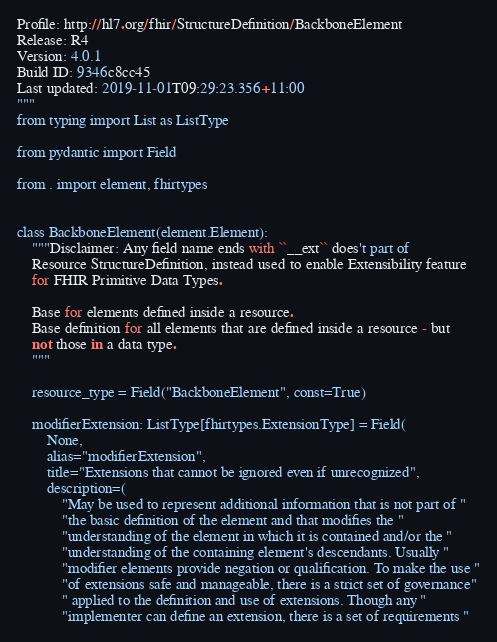<code> <loc_0><loc_0><loc_500><loc_500><_Python_>Profile: http://hl7.org/fhir/StructureDefinition/BackboneElement
Release: R4
Version: 4.0.1
Build ID: 9346c8cc45
Last updated: 2019-11-01T09:29:23.356+11:00
"""
from typing import List as ListType

from pydantic import Field

from . import element, fhirtypes


class BackboneElement(element.Element):
    """Disclaimer: Any field name ends with ``__ext`` does't part of
    Resource StructureDefinition, instead used to enable Extensibility feature
    for FHIR Primitive Data Types.

    Base for elements defined inside a resource.
    Base definition for all elements that are defined inside a resource - but
    not those in a data type.
    """

    resource_type = Field("BackboneElement", const=True)

    modifierExtension: ListType[fhirtypes.ExtensionType] = Field(
        None,
        alias="modifierExtension",
        title="Extensions that cannot be ignored even if unrecognized",
        description=(
            "May be used to represent additional information that is not part of "
            "the basic definition of the element and that modifies the "
            "understanding of the element in which it is contained and/or the "
            "understanding of the containing element's descendants. Usually "
            "modifier elements provide negation or qualification. To make the use "
            "of extensions safe and manageable, there is a strict set of governance"
            " applied to the definition and use of extensions. Though any "
            "implementer can define an extension, there is a set of requirements "</code> 